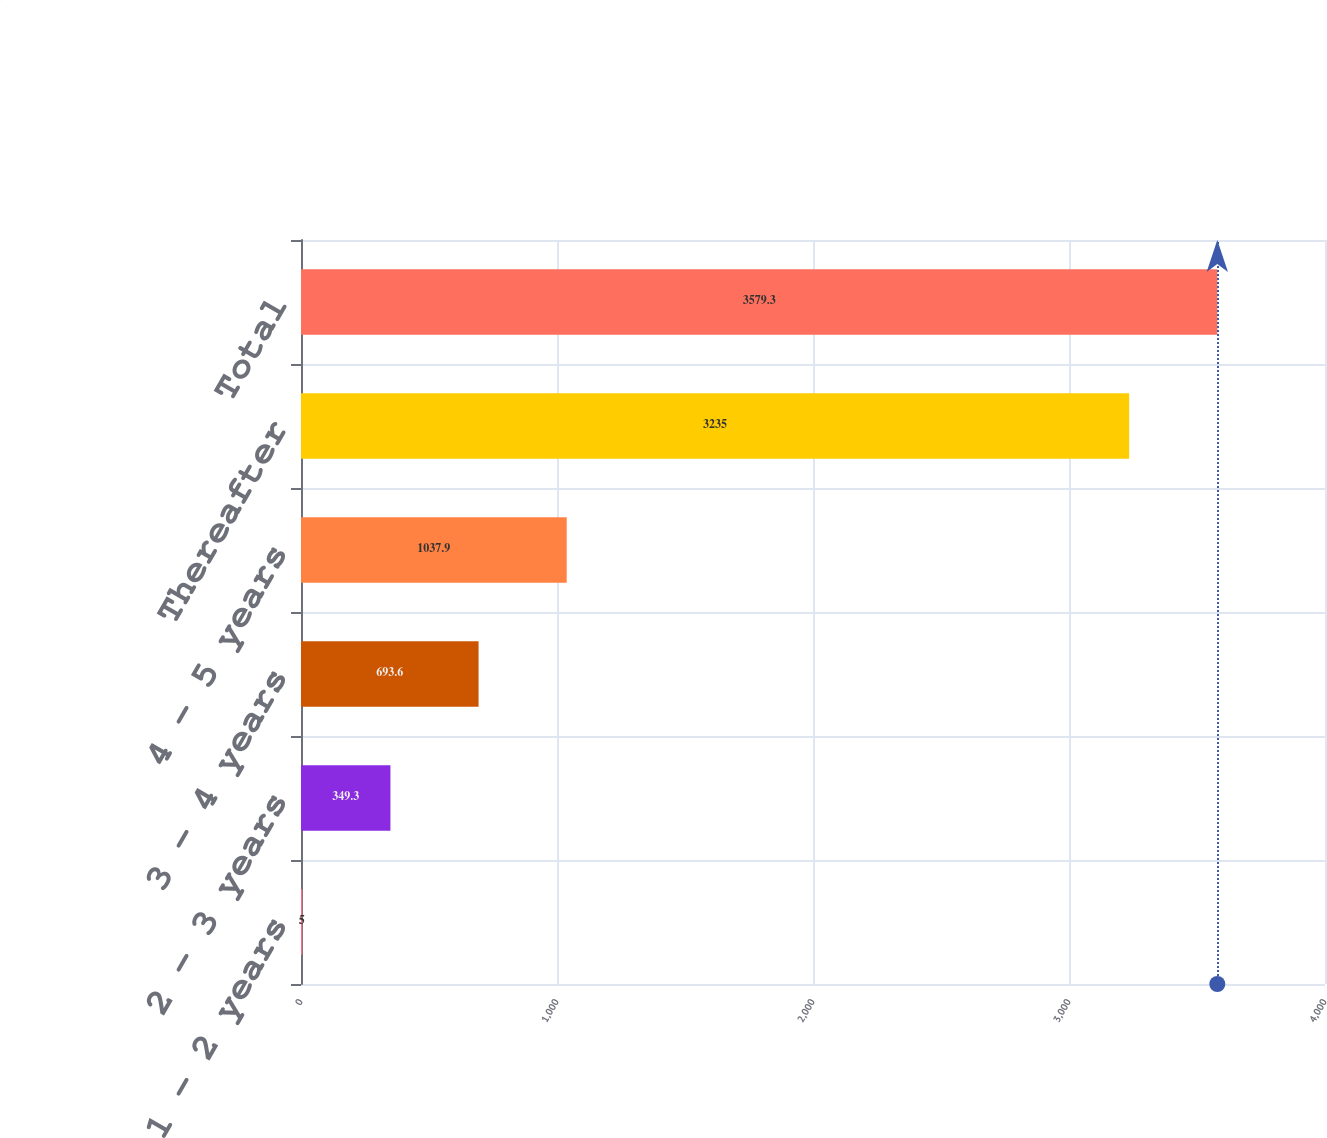Convert chart. <chart><loc_0><loc_0><loc_500><loc_500><bar_chart><fcel>1 - 2 years<fcel>2 - 3 years<fcel>3 - 4 years<fcel>4 - 5 years<fcel>Thereafter<fcel>Total<nl><fcel>5<fcel>349.3<fcel>693.6<fcel>1037.9<fcel>3235<fcel>3579.3<nl></chart> 